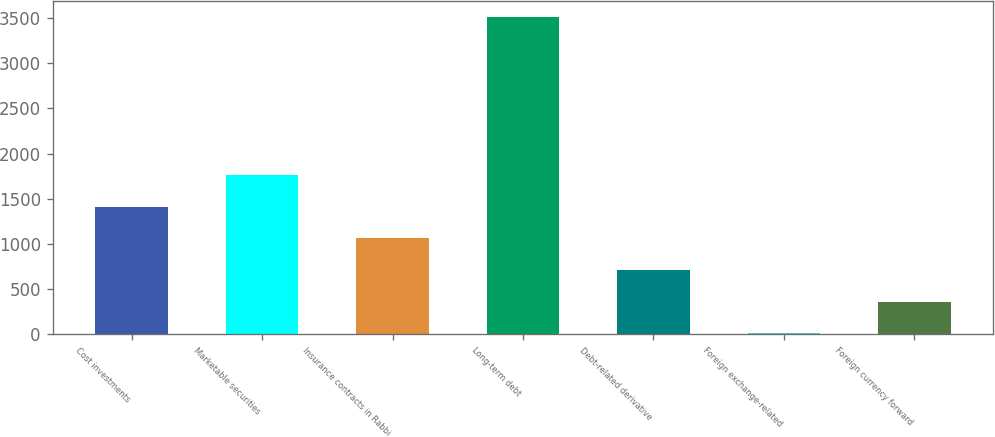Convert chart. <chart><loc_0><loc_0><loc_500><loc_500><bar_chart><fcel>Cost investments<fcel>Marketable securities<fcel>Insurance contracts in Rabbi<fcel>Long-term debt<fcel>Debt-related derivative<fcel>Foreign exchange-related<fcel>Foreign currency forward<nl><fcel>1411.8<fcel>1762.5<fcel>1061.1<fcel>3516<fcel>710.4<fcel>9<fcel>359.7<nl></chart> 